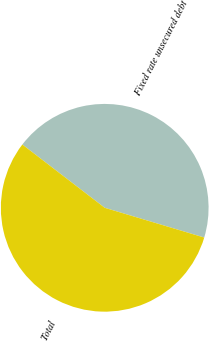<chart> <loc_0><loc_0><loc_500><loc_500><pie_chart><fcel>Fixed rate unsecured debt<fcel>Total<nl><fcel>44.2%<fcel>55.8%<nl></chart> 